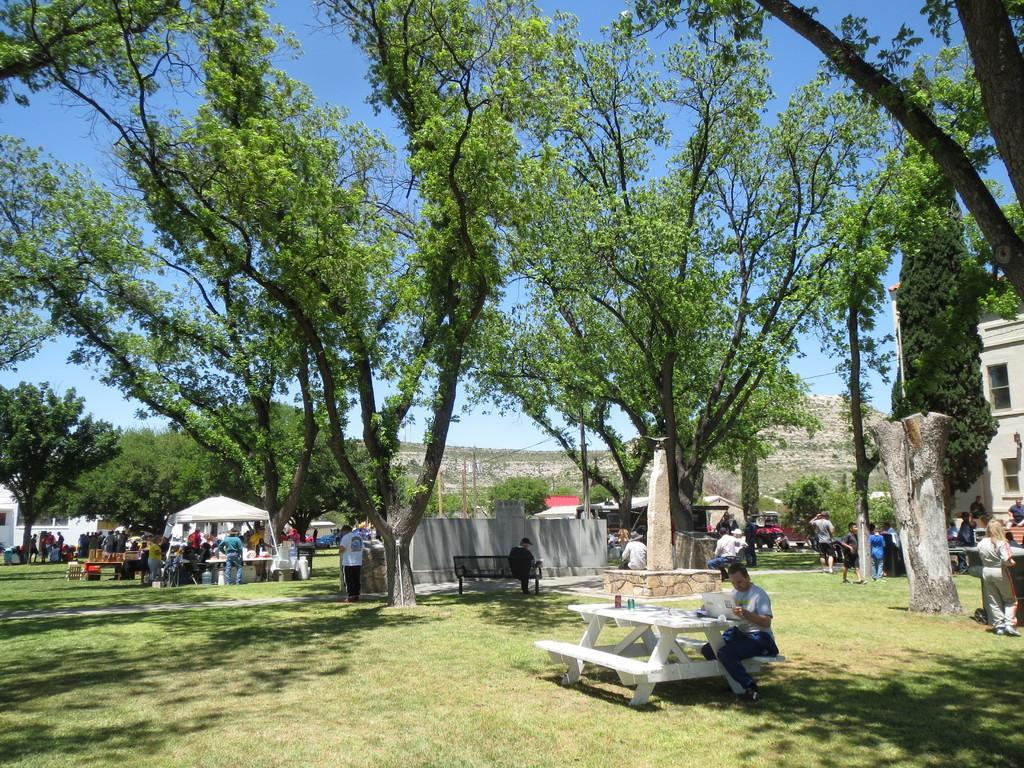Can you describe this image briefly? It is an open space there are lot of people sitting on the tables some of them are standing, it looks like a park and there are many trees in the background there is a hill and sky. 